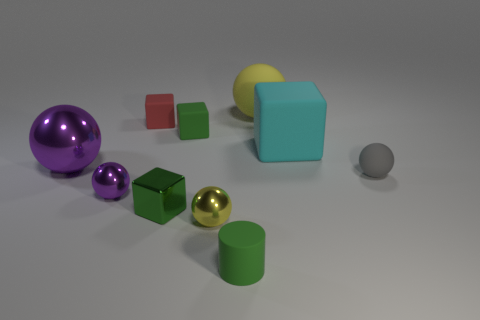Which colored objects in the image are closest to the large teal cube? The objects closest to the large teal cube are two cubes, one is green and the other is red. 